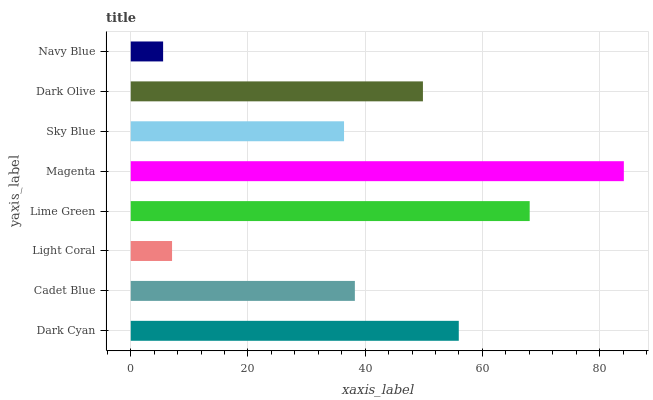Is Navy Blue the minimum?
Answer yes or no. Yes. Is Magenta the maximum?
Answer yes or no. Yes. Is Cadet Blue the minimum?
Answer yes or no. No. Is Cadet Blue the maximum?
Answer yes or no. No. Is Dark Cyan greater than Cadet Blue?
Answer yes or no. Yes. Is Cadet Blue less than Dark Cyan?
Answer yes or no. Yes. Is Cadet Blue greater than Dark Cyan?
Answer yes or no. No. Is Dark Cyan less than Cadet Blue?
Answer yes or no. No. Is Dark Olive the high median?
Answer yes or no. Yes. Is Cadet Blue the low median?
Answer yes or no. Yes. Is Navy Blue the high median?
Answer yes or no. No. Is Dark Cyan the low median?
Answer yes or no. No. 